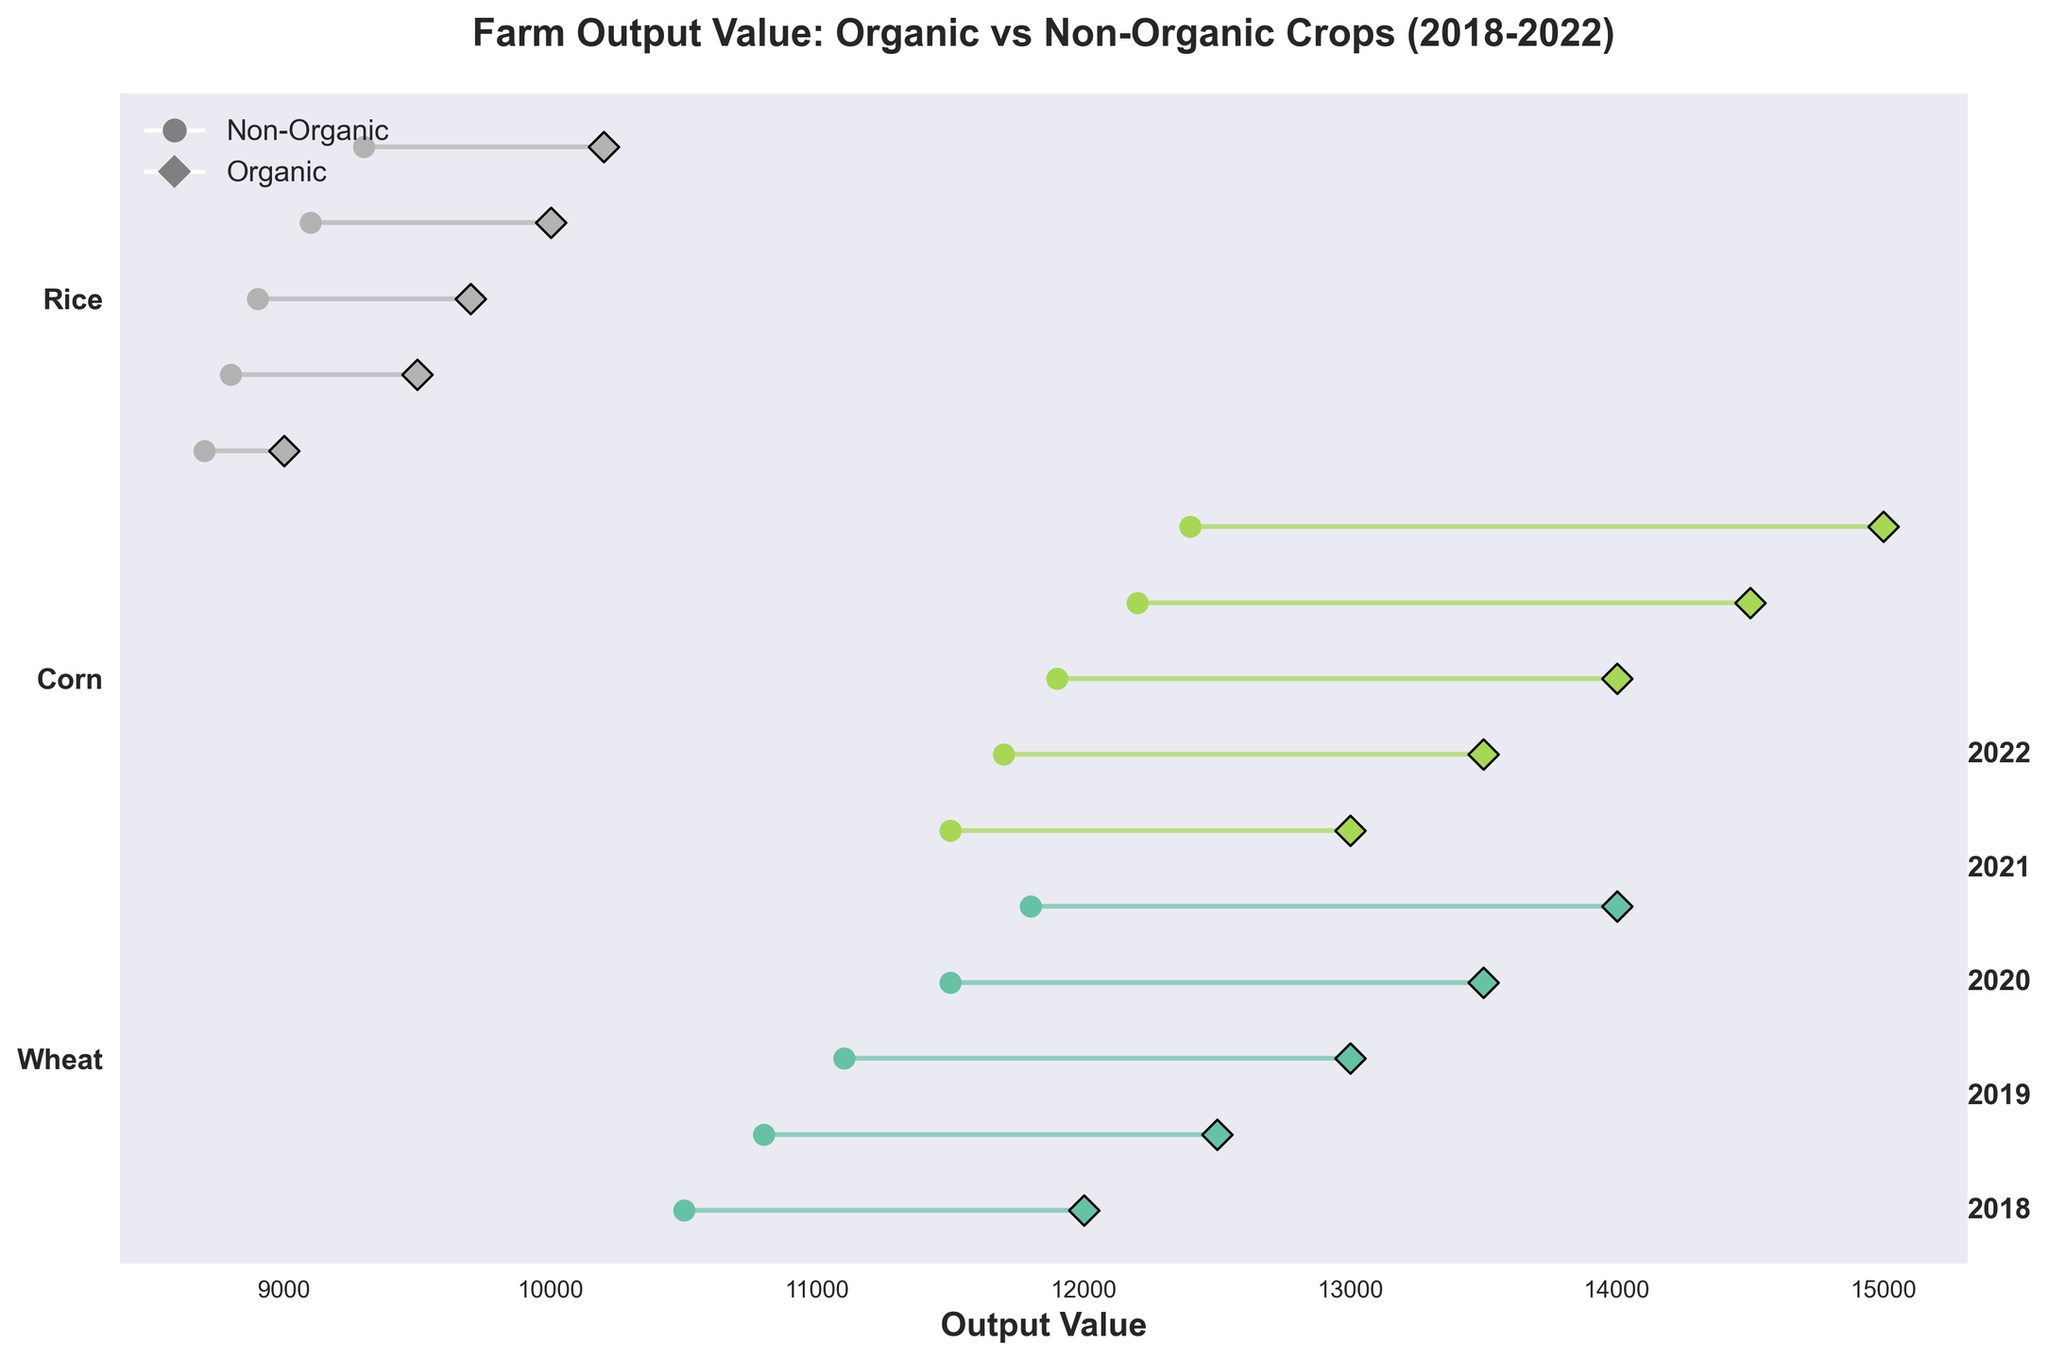What is the title of the plot? The title of the plot is displayed at the top of the figure. It serves as an introduction and summary of the plot’s content.
Answer: Farm Output Value: Organic vs Non-Organic Crops (2018-2022) Which crop had the smallest difference between organic and non-organic output values in 2018? Look at the dumbbell plot for 2018 and compare the lengths of the lines (differences) for each crop. The shortest line indicates the smallest difference.
Answer: Rice How does the non-organic output value of Corn change from 2018 to 2022? Identify and track the position of the non-organic Corn points on the x-axis from 2018 to 2022. Observe the change in x-axis value for each year.
Answer: It increased from 11500 to 12400 In which year did Wheat have the greatest difference between organic and non-organic output values? Identify the dumbbell lines for Wheat in each year and compare their lengths. The longest line indicates the greatest difference.
Answer: 2022 What is the average organic output value for Rice over the years 2018 to 2022? Extract the organic output values for Rice from each year, sum them up, and divide by the number of years. (9000 + 9500 + 9700 + 10000 + 10200) / 5 = 48800 / 5 = 9760
Answer: 9760 Which crop consistently showed higher output values for organic farming compared to non-organic farming across all years? Look across all years and compare the positions of organic and non-organic points for each crop. Determine if any crop's organic points are consistently to the right (higher value) than non-organic points.
Answer: All crops (Wheat, Corn, Rice) For the year 2020, which type of farming had the highest output value for Rice? Look at the dumbbell plot for Rice in 2020 and compare the positions of the organic and non-organic points on the x-axis.
Answer: Organic What trend can you observe about the organic output value of Wheat from 2018 to 2022? Track the position of the organic points for Wheat across the years and note the direction of change.
Answer: It increased every year Did any crop's non-organic output value decrease from 2018 to 2022? Compare the positions of non-organic points for each crop from 2018 to 2022 and note any decreases.
Answer: No Which year had the smallest average difference in output value between organic and non-organic farming for all the crops? Calculate the differences for each crop in each year, then find the average difference for each year. The year with the smallest average difference shows the smallest disparity.
Answer: 2018 